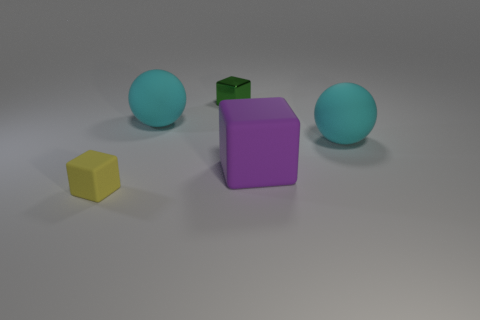There is another block that is the same size as the yellow cube; what is its color?
Your answer should be compact. Green. There is a block that is on the left side of the small thing that is right of the small yellow rubber object; how big is it?
Offer a very short reply. Small. How many other things are there of the same size as the green metallic object?
Your response must be concise. 1. How many cyan spheres are there?
Your answer should be very brief. 2. Is the size of the green shiny cube the same as the purple rubber cube?
Your answer should be compact. No. What number of other things are the same shape as the small green object?
Offer a very short reply. 2. What is the material of the cyan ball to the right of the sphere on the left side of the metallic cube?
Your response must be concise. Rubber. There is a big purple thing; are there any large cyan matte objects right of it?
Offer a terse response. Yes. Do the yellow matte cube and the metal thing that is left of the large purple rubber thing have the same size?
Provide a succinct answer. Yes. There is a green object that is the same shape as the tiny yellow object; what size is it?
Keep it short and to the point. Small. 